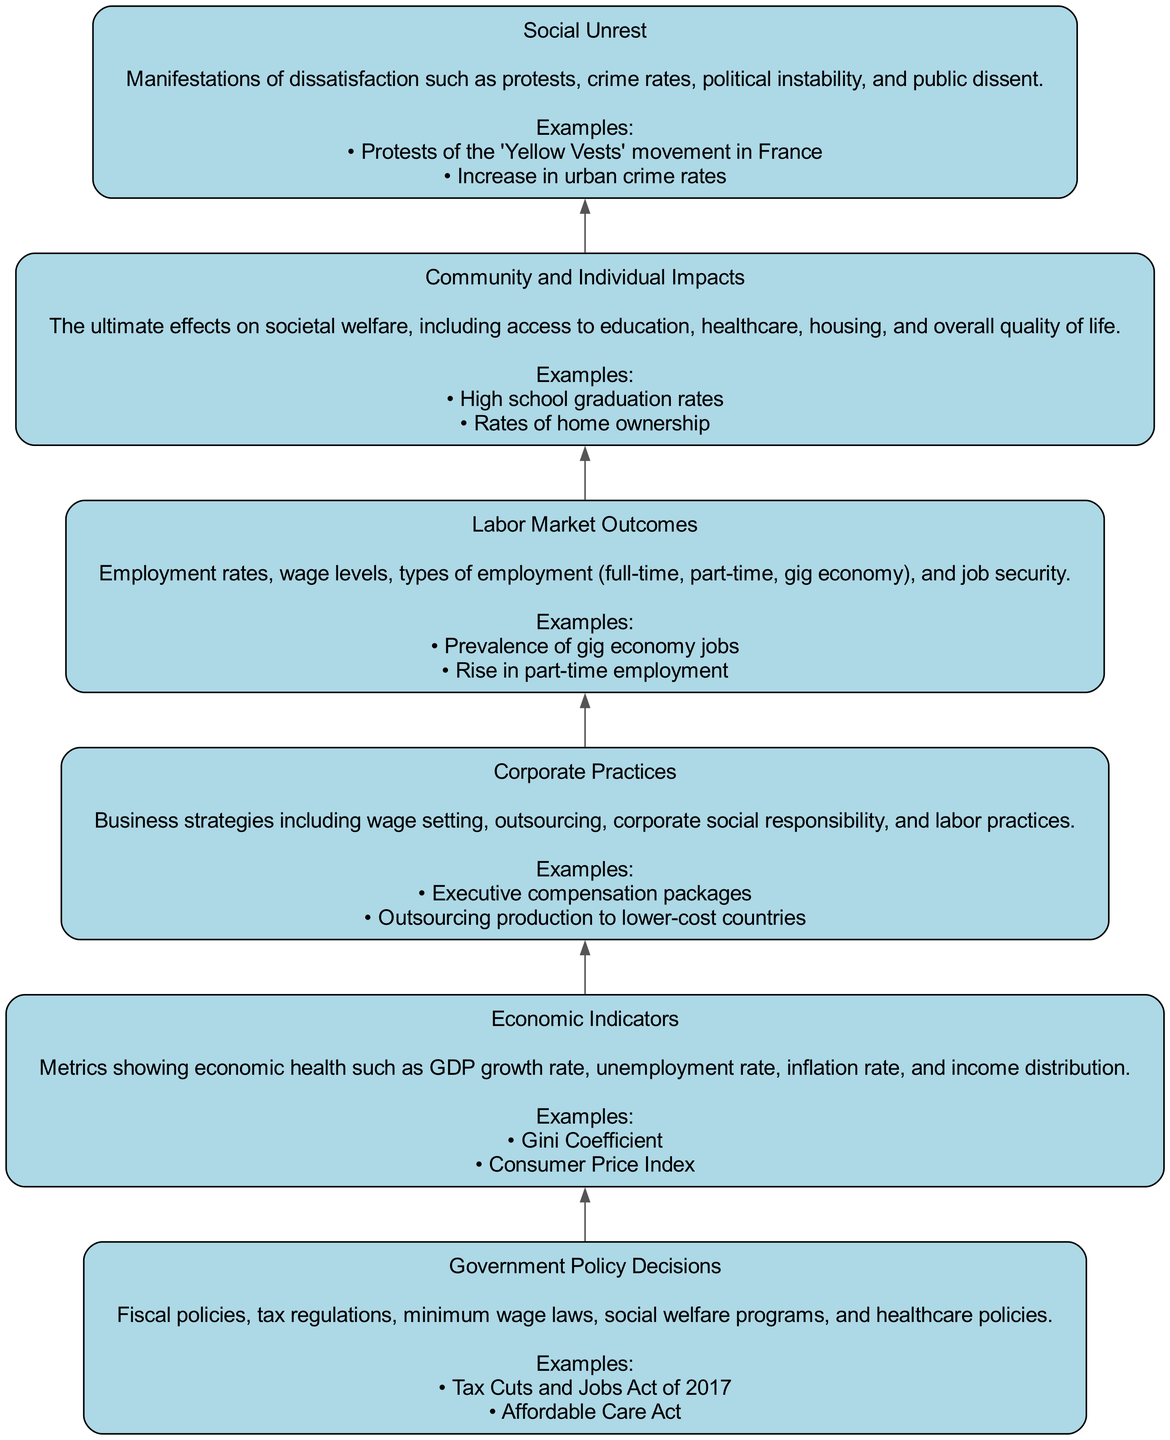What is the first node in the diagram? The first node in the diagram is "Government Policy Decisions". It is positioned at the bottom of the flow chart, indicating it is the starting point for the progression of economic disparities.
Answer: Government Policy Decisions How many nodes are in the diagram? There are a total of six nodes in this diagram, each representing a distinct element of the economic disparity evolution process.
Answer: 6 What is the last node in the diagram? The last node in the diagram is "Social Unrest". It is found at the top, signifying it is the final outcome of the preceding processes detailed in the flow chart.
Answer: Social Unrest What is the connection between "Corporate Practices" and "Labor Market Outcomes"? The diagram indicates a direct edge between "Corporate Practices" and "Labor Market Outcomes", meaning that the practices of corporations influence the results seen in the labor market, such as employment and wage levels.
Answer: Direct influence What does "Community and Individual Impacts" lead to? "Community and Individual Impacts" leads to "Social Unrest". This implies that the effects communities and individuals experience can result in dissatisfaction or unrest, indicating a consequential flow from community impacts to social unrest.
Answer: Social Unrest Which economic indicator is specifically mentioned in the diagram? The "Gini Coefficient" is specifically mentioned as an example of an economic indicator within the node "Economic Indicators", which helps measure income distribution and inequality.
Answer: Gini Coefficient What are two examples of community impacts mentioned? Two examples mentioned are "High school graduation rates" and "Rates of home ownership". These aspects reflect the outcomes that communities face due to economic disparities and policy decisions.
Answer: High school graduation rates, Rates of home ownership What does a change in "Government Policy Decisions" directly influence? A change in "Government Policy Decisions" directly influences "Economic Indicators", suggesting that the decisions made by the government have a measurable effect on the economic health metrics.
Answer: Economic Indicators How does "Labor Market Outcomes" affect social issues? "Labor Market Outcomes" affects "Community and Individual Impacts", meaning the state of the labor market has direct consequences on the well-being of communities and individuals, which can lead to issues such as social unrest.
Answer: Community and Individual Impacts 